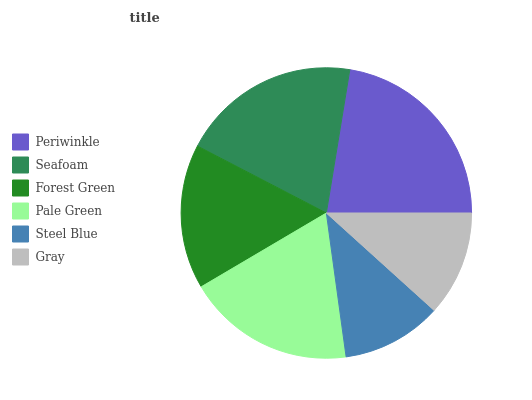Is Steel Blue the minimum?
Answer yes or no. Yes. Is Periwinkle the maximum?
Answer yes or no. Yes. Is Seafoam the minimum?
Answer yes or no. No. Is Seafoam the maximum?
Answer yes or no. No. Is Periwinkle greater than Seafoam?
Answer yes or no. Yes. Is Seafoam less than Periwinkle?
Answer yes or no. Yes. Is Seafoam greater than Periwinkle?
Answer yes or no. No. Is Periwinkle less than Seafoam?
Answer yes or no. No. Is Pale Green the high median?
Answer yes or no. Yes. Is Forest Green the low median?
Answer yes or no. Yes. Is Seafoam the high median?
Answer yes or no. No. Is Pale Green the low median?
Answer yes or no. No. 